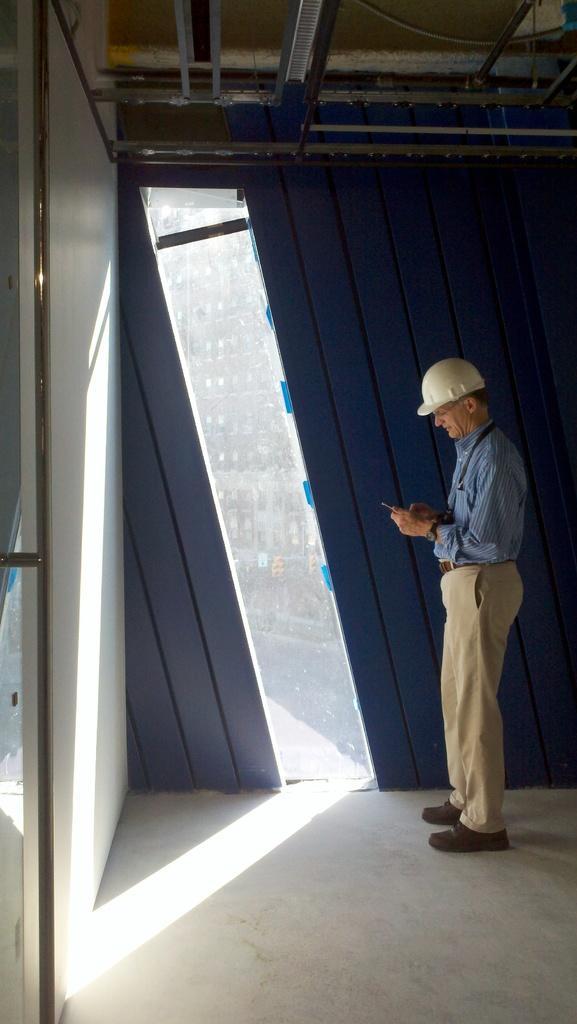Please provide a concise description of this image. The picture is taken inside a room. On the left there is a door and wall. At the top there are pipes and ceiling. In the center of the picture there is a person standing. In the background there is a wall and window. 